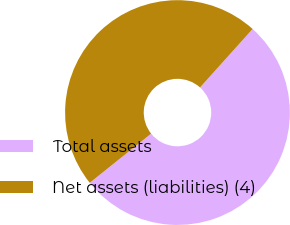<chart> <loc_0><loc_0><loc_500><loc_500><pie_chart><fcel>Total assets<fcel>Net assets (liabilities) (4)<nl><fcel>52.6%<fcel>47.4%<nl></chart> 